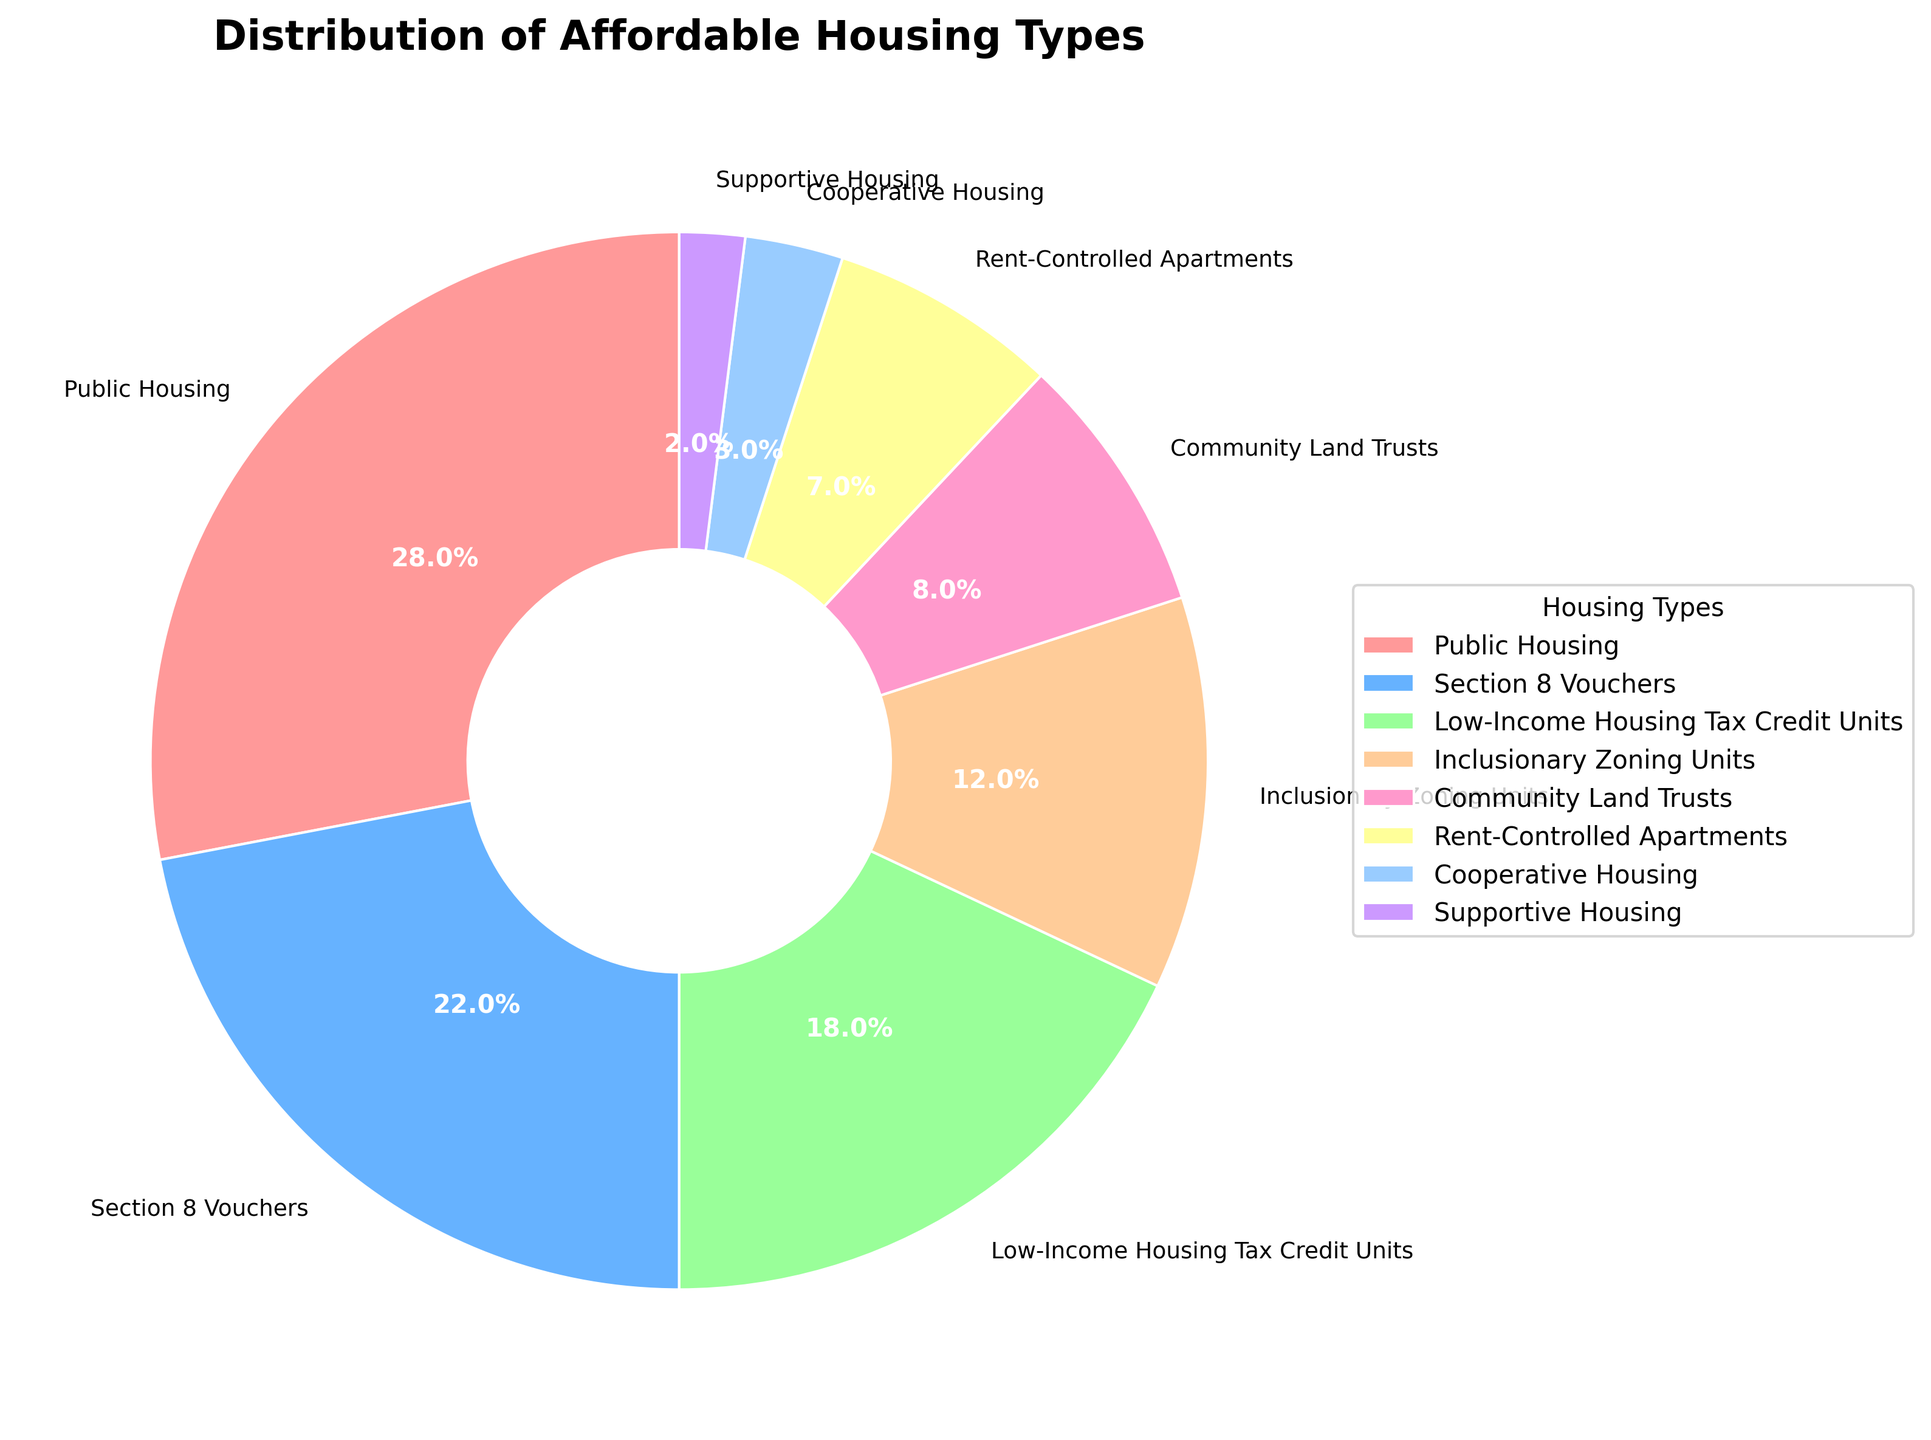What is the housing type with the highest percentage? Looking at the pie chart, the largest segment represents Public Housing, which covers 28% of the distribution.
Answer: Public Housing Which housing type constitutes 22% of the affordable housing? The pie chart shows that the segment representing 22% corresponds to Section 8 Vouchers.
Answer: Section 8 Vouchers Compare the percentages of Low-Income Housing Tax Credit Units and Inclusionary Zoning Units. Which is greater and by how much? From the pie chart, Low-Income Housing Tax Credit Units are 18%, and Inclusionary Zoning Units are 12%. The difference is 18% - 12% = 6%.
Answer: Low-Income Housing Tax Credit Units, 6% What is the combined percentage of Community Land Trusts and Rent-Controlled Apartments? According to the pie chart, Community Land Trusts are 8%, and Rent-Controlled Apartments are 7%. Their combined percentage is 8% + 7% = 15%.
Answer: 15% Which housing type has the smallest percentage, and what is its value? The smallest segment in the pie chart corresponds to Supportive Housing, which is 2%.
Answer: Supportive Housing, 2% How do the percentages of Section 8 Vouchers and Cooperative Housing compare? Section 8 Vouchers have a percentage of 22%, whereas Cooperative Housing has 3%. Section 8 Vouchers are greater by 22% - 3% = 19%.
Answer: Section 8 Vouchers, 19% What is the percentage of Public Housing compared to the sum of Cooperative Housing and Supportive Housing? Public Housing is at 28%, while Cooperative Housing and Supportive Housing sum up to 3% + 2% = 5%. Public Housing is greater by 28% - 5% = 23%.
Answer: 23% Which two housing types together represent exactly 30% of the distribution? Rent-Controlled Apartments (7%) and Section 8 Vouchers (22%) sum up to 7% + 22% = 29%, but Rent-Controlled Apartments (7%) and Inclusionary Zoning Units (12%) sum up to 7% + 12% = 19%, so Community Land Trusts (8%) and Low-Income Housing Tax Credit Units (18%) together are 8% + 18% = 26%, thus Public Housing (28%) and Supportive Housing (2%) together represent 28% + 2% = 30%.
Answer: Public Housing and Supportive Housing 